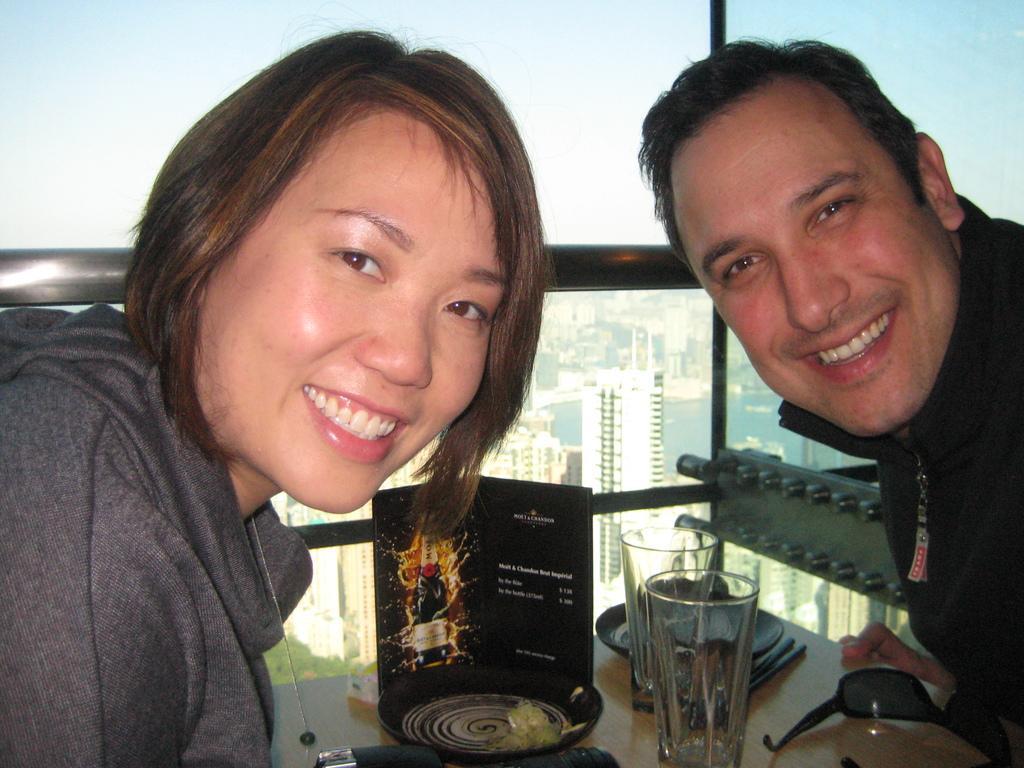Could you give a brief overview of what you see in this image? Here I can see a woman and a man smiling and giving pose for the picture. In the middle of these two persons there is a table on which glasses, plates, chopsticks, goggles, a card and some other objects are placed. In the background there is a glass through which we can see the outside view. In the outside there are many buildings and a sea. At the top of the image I can see the sky. 